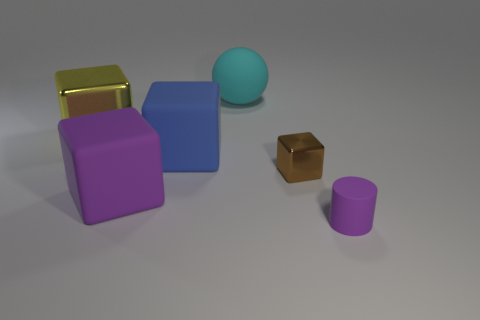There is a purple cube that is left of the thing behind the big yellow thing; what is it made of?
Your response must be concise. Rubber. Is there a large green cylinder made of the same material as the purple cube?
Keep it short and to the point. No. Do the blue thing and the purple object that is on the right side of the large blue thing have the same material?
Give a very brief answer. Yes. There is another thing that is the same size as the brown object; what is its color?
Give a very brief answer. Purple. How big is the shiny thing that is to the right of the object that is behind the big yellow metallic cube?
Offer a terse response. Small. There is a small cylinder; is its color the same as the metallic cube that is on the right side of the cyan rubber thing?
Provide a succinct answer. No. Is the number of yellow metal cubes that are in front of the blue thing less than the number of large yellow objects?
Keep it short and to the point. Yes. What number of other objects are the same size as the blue matte block?
Give a very brief answer. 3. Do the large metallic thing that is on the left side of the blue matte thing and the cyan thing have the same shape?
Keep it short and to the point. No. Are there more rubber cubes left of the big purple object than large blocks?
Keep it short and to the point. No. 